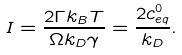<formula> <loc_0><loc_0><loc_500><loc_500>I = \frac { 2 \Gamma k _ { B } T } { \Omega k _ { D } \gamma } = \frac { 2 c ^ { 0 } _ { e q } } { k _ { D } } .</formula> 